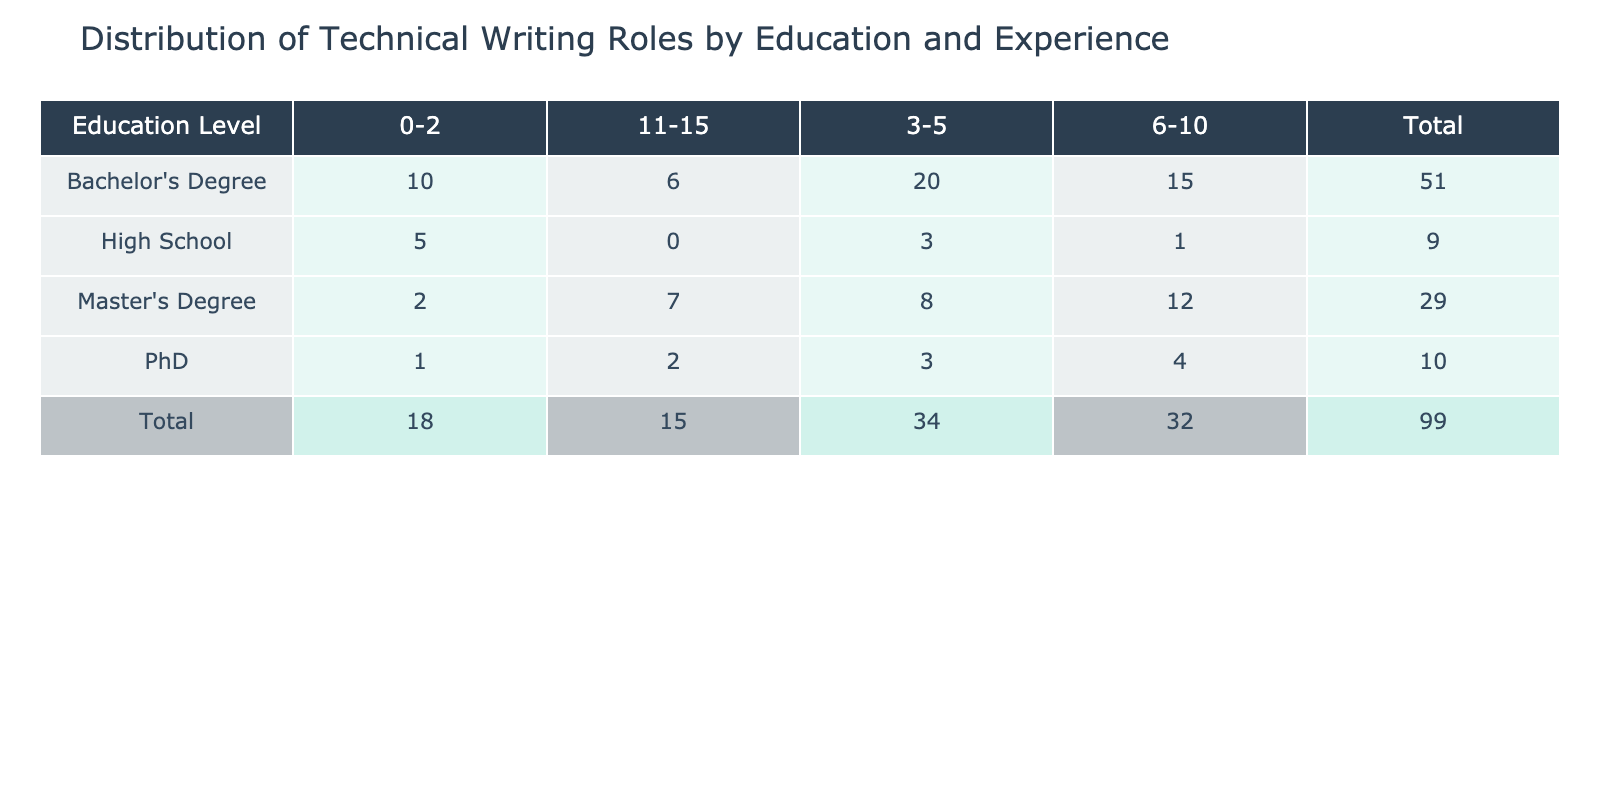What is the total role count for individuals with a Bachelor's Degree? The row for Bachelor's Degree lists role counts across different experience ranges. To find the total, we sum the counts: (10 + 20 + 15 + 6) = 51.
Answer: 51 Which education level has the least number of roles for individuals with 0-2 years of experience? Comparing the role counts for 0-2 years of experience: High School (5), Bachelor's Degree (10), Master's Degree (2), PhD (1). The education level with the least is PhD with just 1 role.
Answer: PhD What is the average number of roles for individuals with a Master's Degree across all experience levels? Summing the counts for Master's Degree: (2 + 8 + 12 + 7) = 29. There are 4 data points (experience levels), so the average is 29/4 = 7.25.
Answer: 7.25 True or False: The total role count for individuals with a Master's Degree is greater than that for those with a High School education. The total for Master's Degree is (29) and for High School it is (9). Since 29 > 9, the statement is true.
Answer: True What is the difference in total roles between individuals with a Bachelor's Degree and those with a Master's Degree? Total roles for Bachelor's Degree (51) and Master's Degree (29). The difference is 51 - 29 = 22.
Answer: 22 Which experience range has the highest number of roles for individuals with a Bachelor's Degree? Reviewing the counts: 0-2 (10), 3-5 (20), 6-10 (15), 11-15 (6). The highest count is in the 3-5 years range with 20 roles.
Answer: 3-5 years What is the total role count for technical writers with 6-10 years of experience? The counts across education levels for 6-10 years are: High School (1), Bachelor's Degree (15), Master's Degree (12), PhD (4). Summing these gives 1 + 15 + 12 + 4 = 32.
Answer: 32 Is it true that individuals with a High School education have more total roles than those with a PhD? The total for High School is 9, while for PhD it is 10. Since 9 is not greater than 10, this statement is false.
Answer: False What is the total role count for individuals with 3-5 years of experience? The counts for 3-5 years are: High School (3), Bachelor's Degree (20), Master's Degree (8), PhD (3). Adding these gives 3 + 20 + 8 + 3 = 34.
Answer: 34 